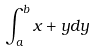<formula> <loc_0><loc_0><loc_500><loc_500>\int _ { a } ^ { b } x + y d y</formula> 